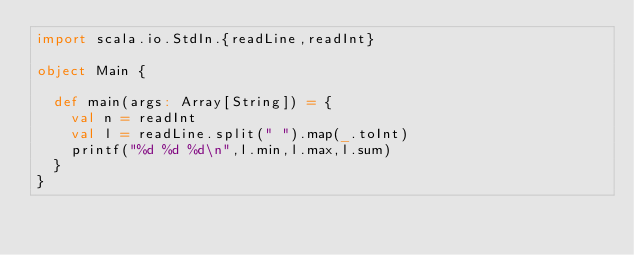Convert code to text. <code><loc_0><loc_0><loc_500><loc_500><_Scala_>import scala.io.StdIn.{readLine,readInt}

object Main {

  def main(args: Array[String]) = {
    val n = readInt
    val l = readLine.split(" ").map(_.toInt)
    printf("%d %d %d\n",l.min,l.max,l.sum)
  }
}</code> 